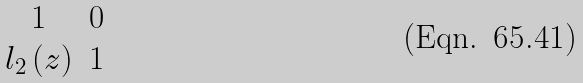Convert formula to latex. <formula><loc_0><loc_0><loc_500><loc_500>\begin{matrix} 1 & 0 \\ l _ { 2 } \left ( z \right ) & 1 \end{matrix}</formula> 